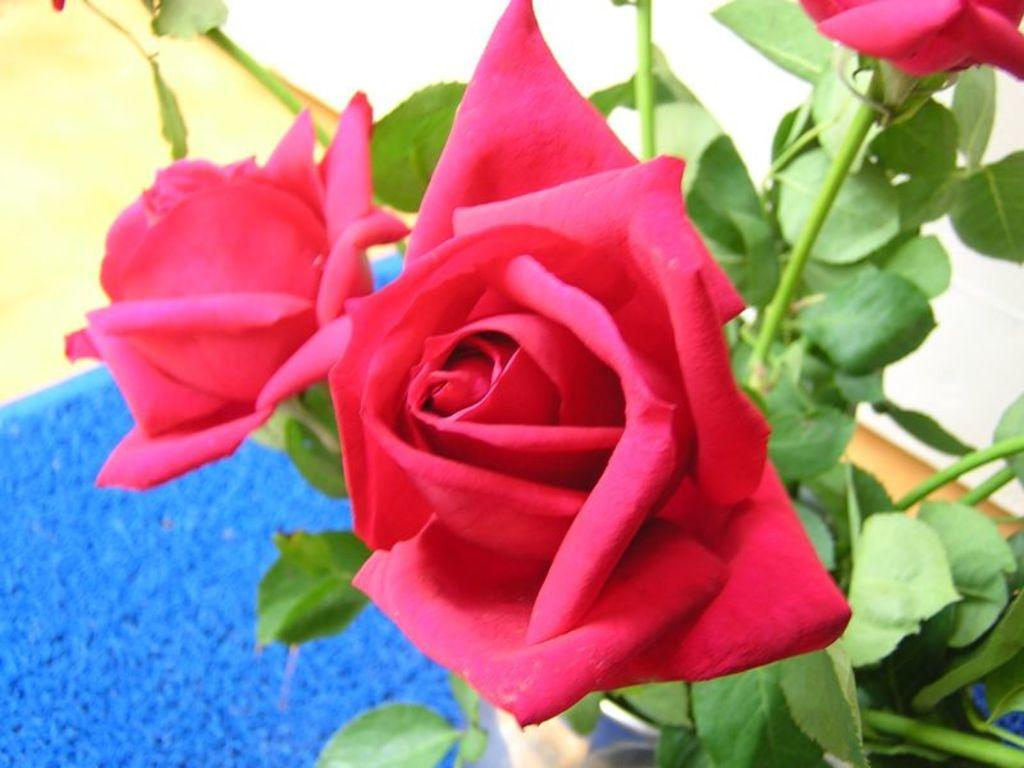What type of plant is in the image? There is a plant in the image, and it has roses. What other features can be seen on the plant? The plant also has leaves. What can be seen in the background of the image? There are objects in the background of the image. Where is the nest located in the image? There is no nest present in the image. What subject is the plant teaching in the image? Plants do not teach subjects; they are living organisms. 